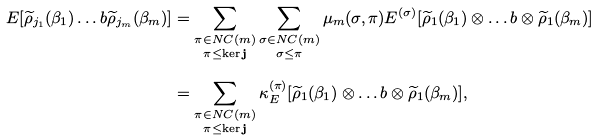<formula> <loc_0><loc_0><loc_500><loc_500>E [ \widetilde { \rho } _ { j _ { 1 } } ( \beta _ { 1 } ) \dots b \widetilde { \rho } _ { j _ { m } } ( \beta _ { m } ) ] & = \sum _ { \substack { \pi \in N C ( m ) \\ \pi \leq \ker \mathbf j } } \sum _ { \substack { \sigma \in N C ( m ) \\ \sigma \leq \pi } } \mu _ { m } ( \sigma , \pi ) E ^ { ( \sigma ) } [ \widetilde { \rho } _ { 1 } ( \beta _ { 1 } ) \otimes \dots b \otimes \widetilde { \rho } _ { 1 } ( \beta _ { m } ) ] \\ & = \sum _ { \substack { \pi \in N C ( m ) \\ \pi \leq \ker \mathbf j } } \kappa _ { E } ^ { ( \pi ) } [ \widetilde { \rho } _ { 1 } ( \beta _ { 1 } ) \otimes \dots b \otimes \widetilde { \rho } _ { 1 } ( \beta _ { m } ) ] ,</formula> 